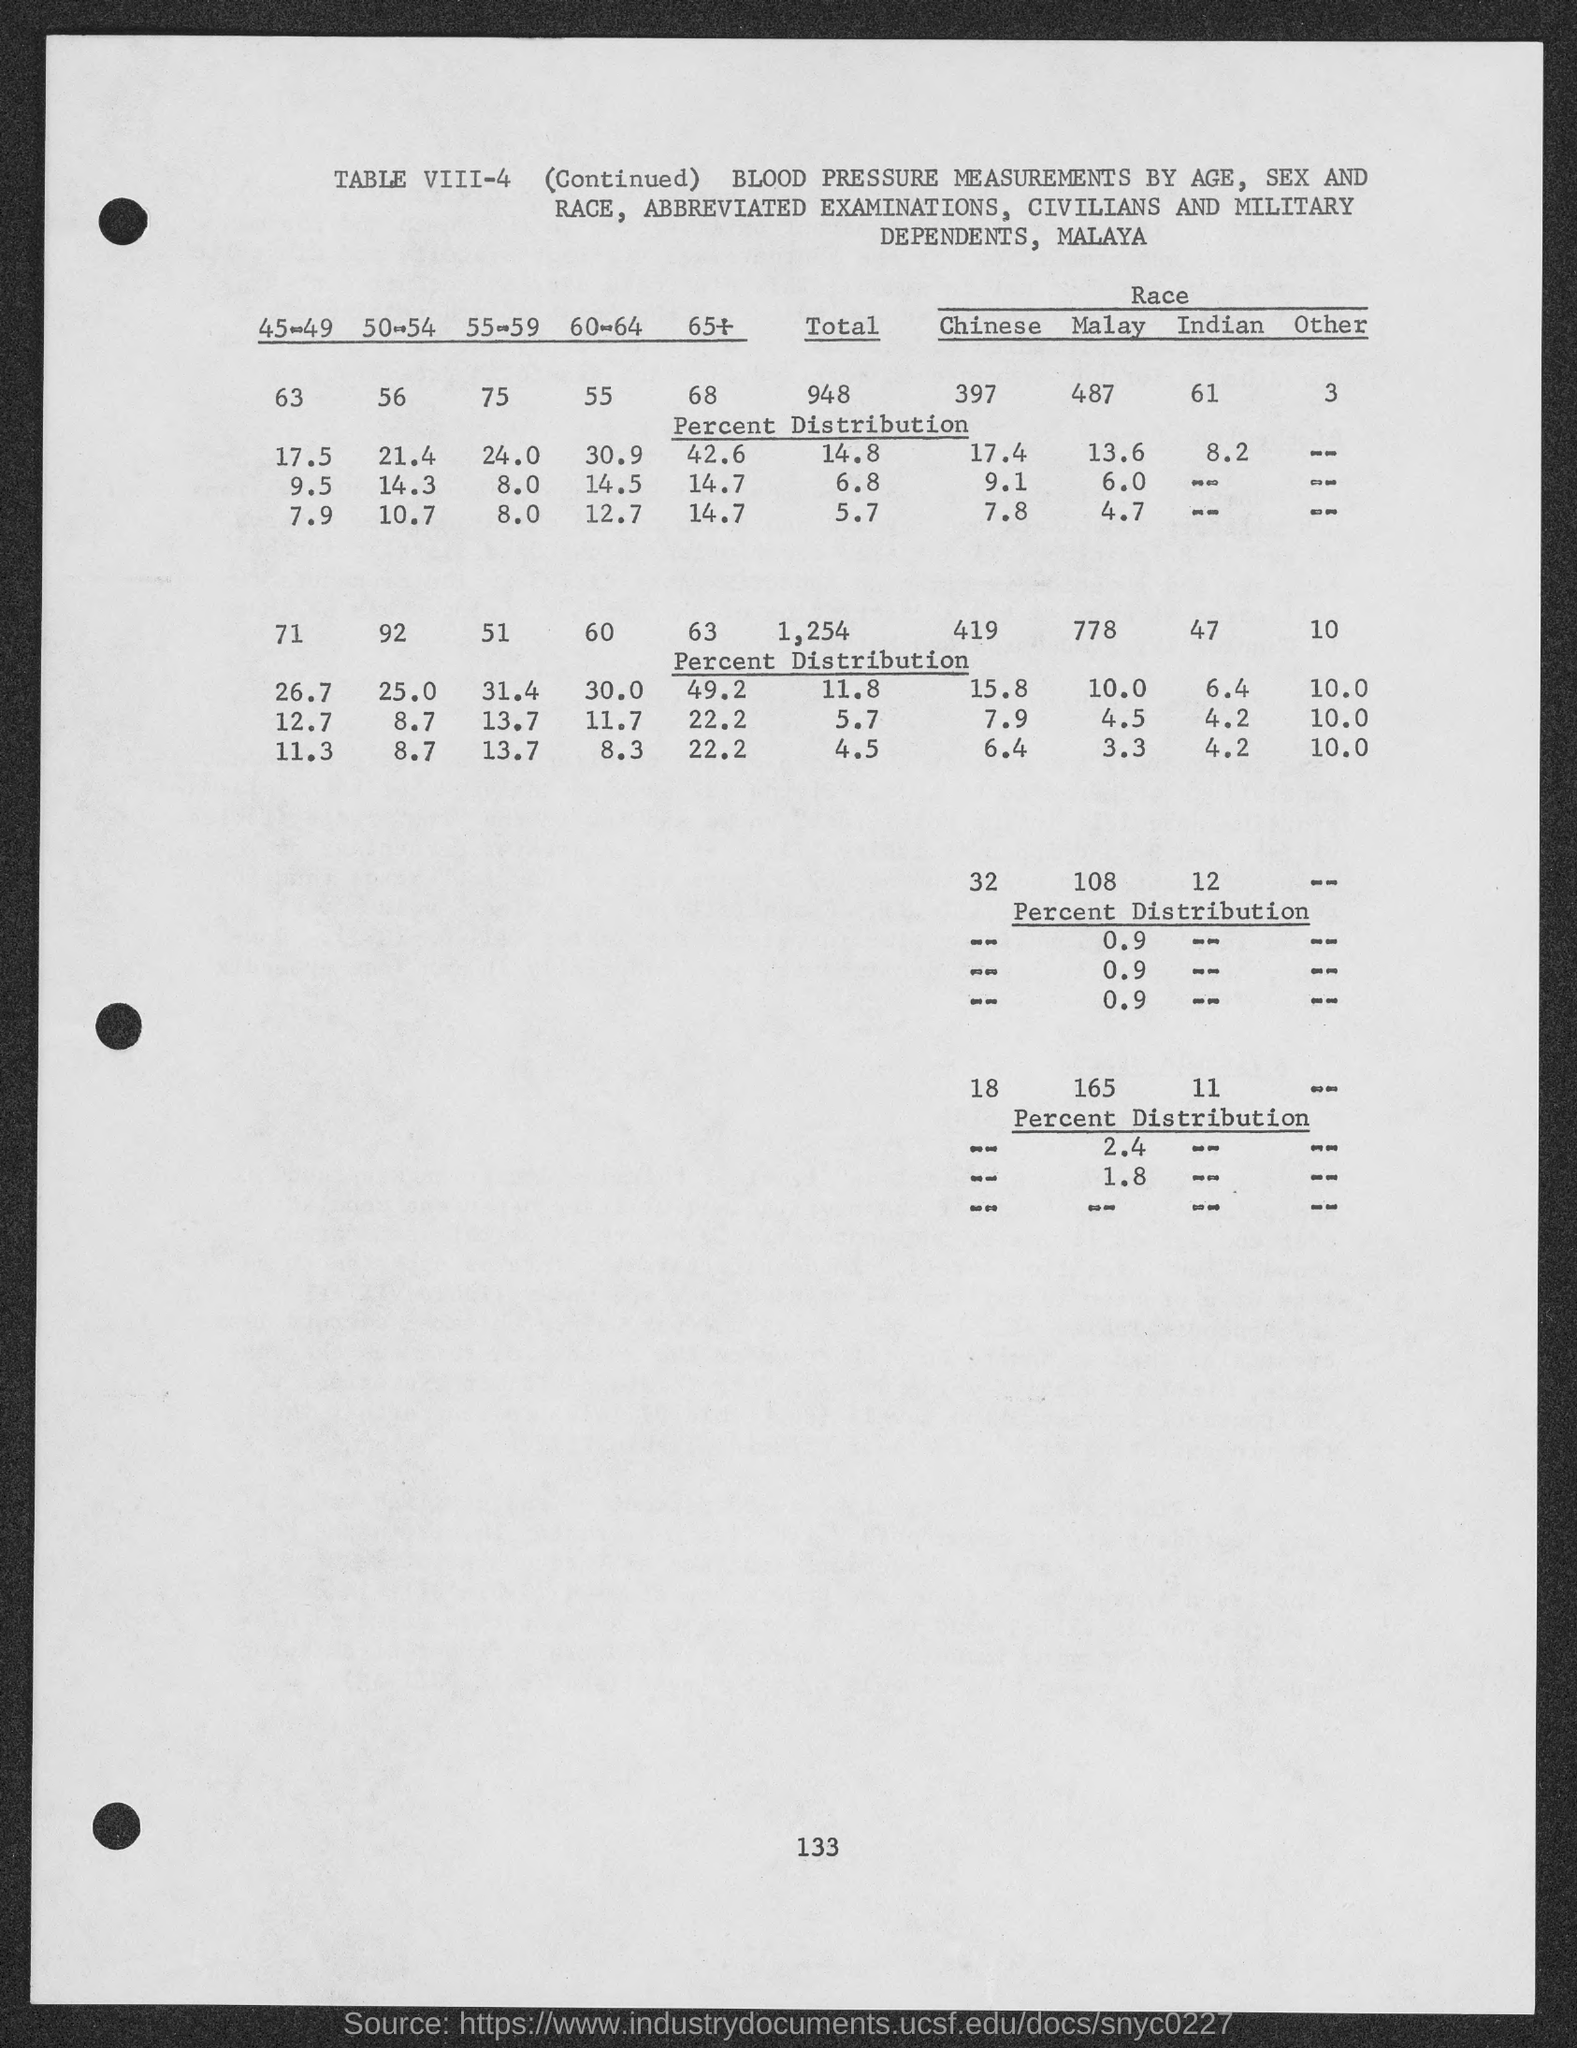Draw attention to some important aspects in this diagram. The table number is VIII-4. The number at the bottom of the page is 133. 